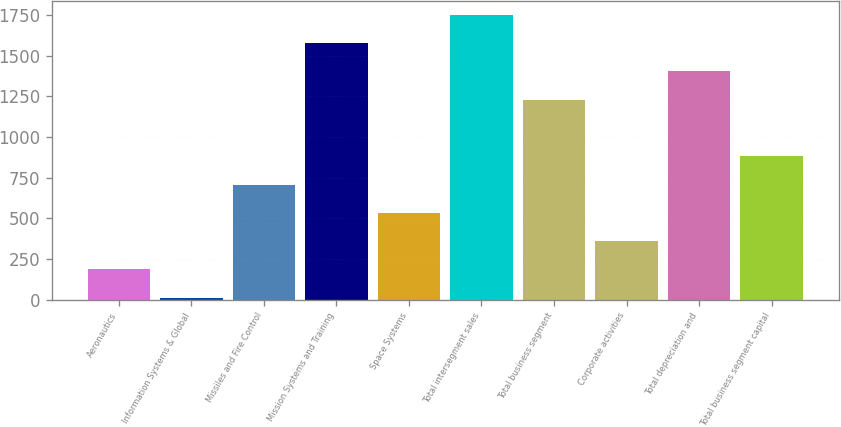Convert chart to OTSL. <chart><loc_0><loc_0><loc_500><loc_500><bar_chart><fcel>Aeronautics<fcel>Information Systems & Global<fcel>Missiles and Fire Control<fcel>Mission Systems and Training<fcel>Space Systems<fcel>Total intersegment sales<fcel>Total business segment<fcel>Corporate activities<fcel>Total depreciation and<fcel>Total business segment capital<nl><fcel>185.8<fcel>12<fcel>707.2<fcel>1576.2<fcel>533.4<fcel>1750<fcel>1228.6<fcel>359.6<fcel>1402.4<fcel>881<nl></chart> 